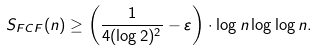Convert formula to latex. <formula><loc_0><loc_0><loc_500><loc_500>S _ { F C F } ( n ) \geq \left ( \frac { 1 } { 4 ( \log 2 ) ^ { 2 } } - \varepsilon \right ) \cdot \log n \log \log n .</formula> 